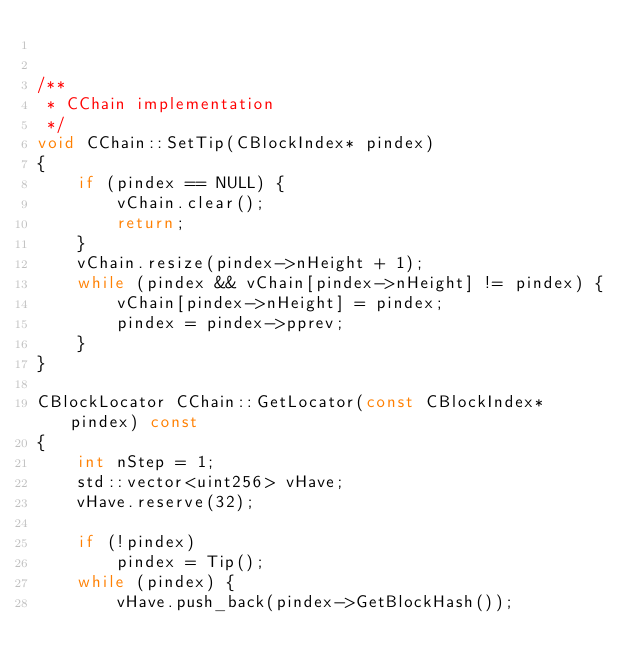Convert code to text. <code><loc_0><loc_0><loc_500><loc_500><_C++_>

/**
 * CChain implementation
 */
void CChain::SetTip(CBlockIndex* pindex)
{
    if (pindex == NULL) {
        vChain.clear();
        return;
    }
    vChain.resize(pindex->nHeight + 1);
    while (pindex && vChain[pindex->nHeight] != pindex) {
        vChain[pindex->nHeight] = pindex;
        pindex = pindex->pprev;
    }
}

CBlockLocator CChain::GetLocator(const CBlockIndex* pindex) const
{
    int nStep = 1;
    std::vector<uint256> vHave;
    vHave.reserve(32);

    if (!pindex)
        pindex = Tip();
    while (pindex) {
        vHave.push_back(pindex->GetBlockHash());</code> 